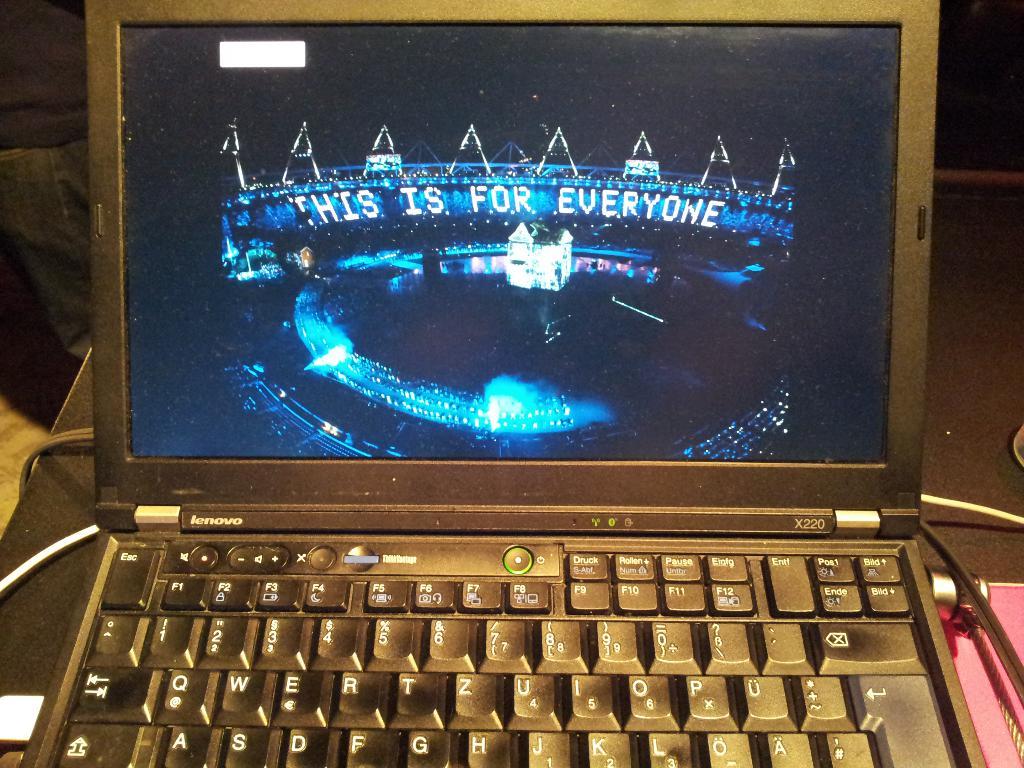Who is this for?
Your answer should be very brief. Everyone. What is the manufacturer of the laptop?
Give a very brief answer. Lenovo. 